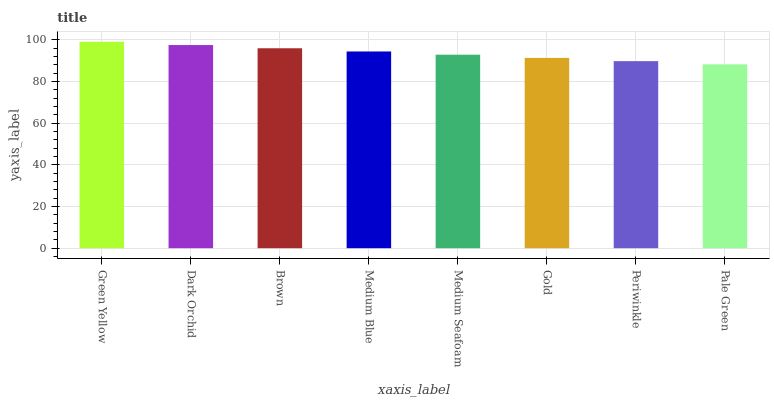Is Pale Green the minimum?
Answer yes or no. Yes. Is Green Yellow the maximum?
Answer yes or no. Yes. Is Dark Orchid the minimum?
Answer yes or no. No. Is Dark Orchid the maximum?
Answer yes or no. No. Is Green Yellow greater than Dark Orchid?
Answer yes or no. Yes. Is Dark Orchid less than Green Yellow?
Answer yes or no. Yes. Is Dark Orchid greater than Green Yellow?
Answer yes or no. No. Is Green Yellow less than Dark Orchid?
Answer yes or no. No. Is Medium Blue the high median?
Answer yes or no. Yes. Is Medium Seafoam the low median?
Answer yes or no. Yes. Is Pale Green the high median?
Answer yes or no. No. Is Pale Green the low median?
Answer yes or no. No. 